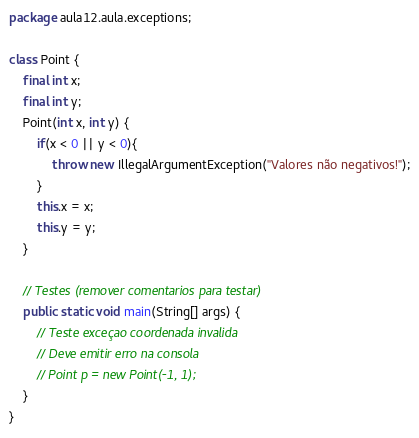Convert code to text. <code><loc_0><loc_0><loc_500><loc_500><_Java_>package aula12.aula.exceptions;

class Point {
    final int x;
    final int y;
    Point(int x, int y) {
        if(x < 0 || y < 0){
            throw new IllegalArgumentException("Valores não negativos!");
        }
        this.x = x;
        this.y = y;
    }

    // Testes (remover comentarios para testar)
    public static void main(String[] args) {
        // Teste exceçao coordenada invalida
        // Deve emitir erro na consola
        // Point p = new Point(-1, 1);
    }
}</code> 